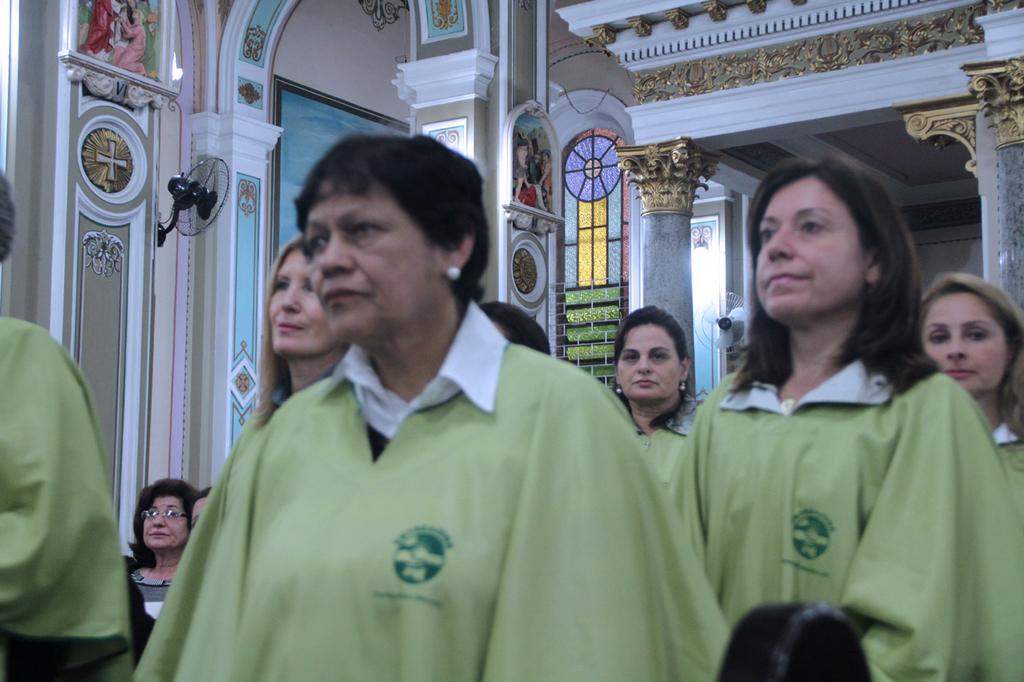How many people are in the image? There is a group of people standing in the image, and two persons are sitting. What are the people in the image doing? The people in the image are standing and sitting. What can be seen on the wall in the image? There are fans on the wall in the image. What type of butter is being used by the people in the image? There is no butter present in the image; it features a group of people standing and sitting, along with fans on the wall. What landmarks can be seen in the image? The image does not depict any landmarks; it focuses on the people and the fans on the wall. 